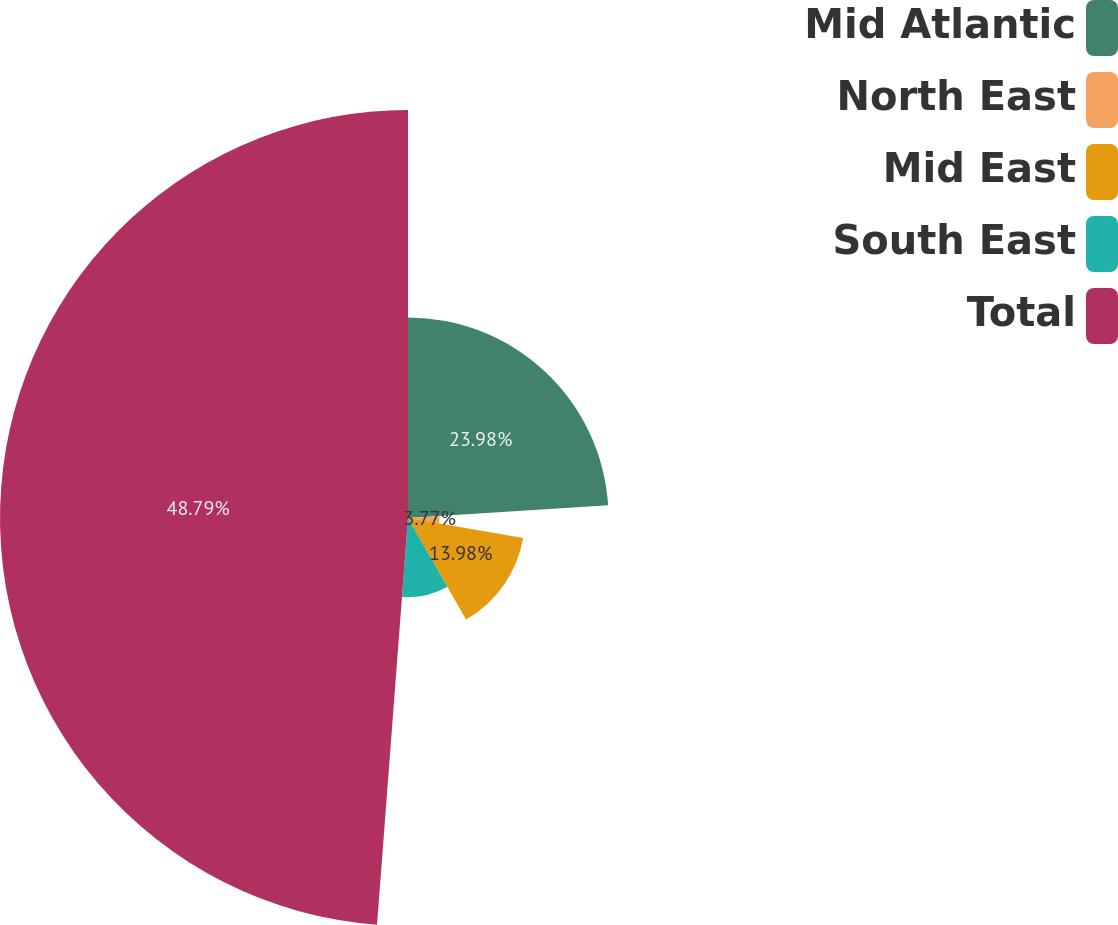<chart> <loc_0><loc_0><loc_500><loc_500><pie_chart><fcel>Mid Atlantic<fcel>North East<fcel>Mid East<fcel>South East<fcel>Total<nl><fcel>23.98%<fcel>3.77%<fcel>13.98%<fcel>9.48%<fcel>48.79%<nl></chart> 